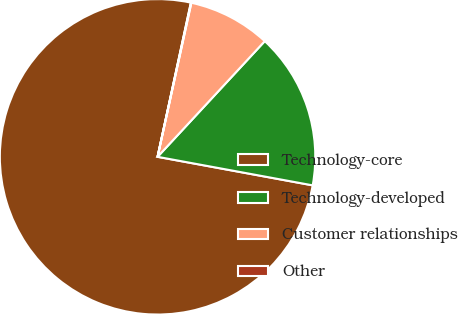Convert chart. <chart><loc_0><loc_0><loc_500><loc_500><pie_chart><fcel>Technology-core<fcel>Technology-developed<fcel>Customer relationships<fcel>Other<nl><fcel>75.49%<fcel>16.0%<fcel>8.46%<fcel>0.05%<nl></chart> 